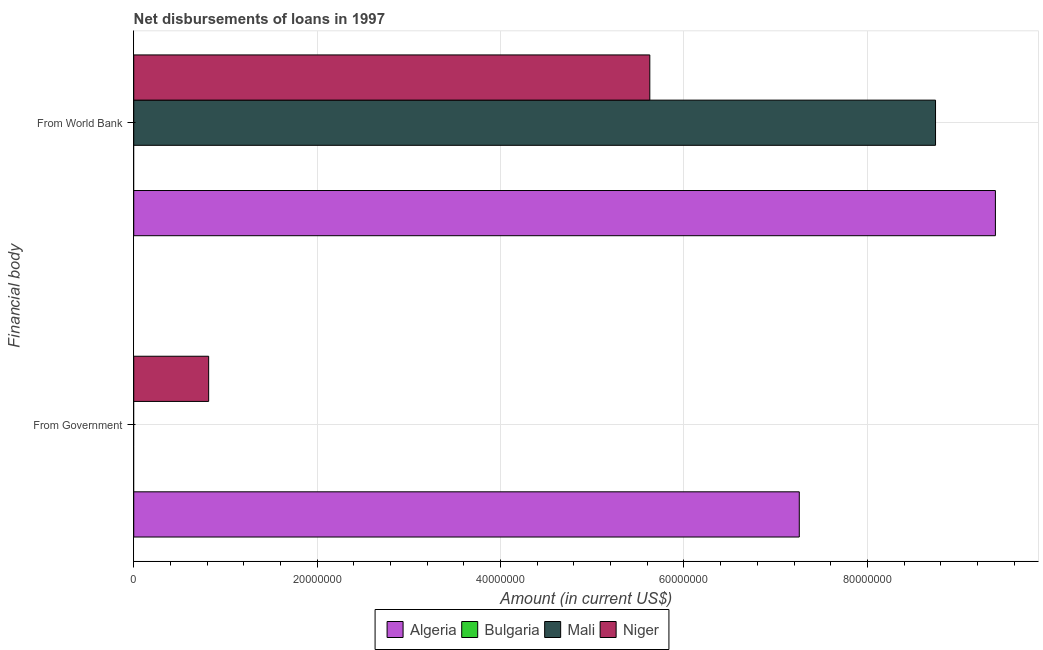How many different coloured bars are there?
Your response must be concise. 3. Are the number of bars per tick equal to the number of legend labels?
Offer a very short reply. No. Are the number of bars on each tick of the Y-axis equal?
Make the answer very short. No. How many bars are there on the 2nd tick from the top?
Your answer should be compact. 2. How many bars are there on the 2nd tick from the bottom?
Offer a terse response. 3. What is the label of the 2nd group of bars from the top?
Your response must be concise. From Government. What is the net disbursements of loan from government in Bulgaria?
Keep it short and to the point. 0. Across all countries, what is the maximum net disbursements of loan from government?
Offer a very short reply. 7.26e+07. Across all countries, what is the minimum net disbursements of loan from world bank?
Offer a very short reply. 0. In which country was the net disbursements of loan from world bank maximum?
Ensure brevity in your answer.  Algeria. What is the total net disbursements of loan from government in the graph?
Your answer should be compact. 8.07e+07. What is the difference between the net disbursements of loan from world bank in Algeria and that in Mali?
Your answer should be compact. 6.53e+06. What is the difference between the net disbursements of loan from government in Algeria and the net disbursements of loan from world bank in Niger?
Your answer should be very brief. 1.63e+07. What is the average net disbursements of loan from world bank per country?
Make the answer very short. 5.94e+07. What is the difference between the net disbursements of loan from world bank and net disbursements of loan from government in Niger?
Your response must be concise. 4.81e+07. In how many countries, is the net disbursements of loan from world bank greater than 84000000 US$?
Offer a terse response. 2. What is the ratio of the net disbursements of loan from government in Algeria to that in Niger?
Ensure brevity in your answer.  8.88. In how many countries, is the net disbursements of loan from government greater than the average net disbursements of loan from government taken over all countries?
Give a very brief answer. 1. Are all the bars in the graph horizontal?
Your response must be concise. Yes. How many countries are there in the graph?
Keep it short and to the point. 4. Does the graph contain any zero values?
Keep it short and to the point. Yes. How many legend labels are there?
Give a very brief answer. 4. How are the legend labels stacked?
Offer a very short reply. Horizontal. What is the title of the graph?
Offer a terse response. Net disbursements of loans in 1997. Does "Croatia" appear as one of the legend labels in the graph?
Make the answer very short. No. What is the label or title of the X-axis?
Offer a terse response. Amount (in current US$). What is the label or title of the Y-axis?
Provide a short and direct response. Financial body. What is the Amount (in current US$) in Algeria in From Government?
Offer a very short reply. 7.26e+07. What is the Amount (in current US$) in Niger in From Government?
Offer a terse response. 8.17e+06. What is the Amount (in current US$) in Algeria in From World Bank?
Offer a terse response. 9.40e+07. What is the Amount (in current US$) of Bulgaria in From World Bank?
Provide a succinct answer. 0. What is the Amount (in current US$) of Mali in From World Bank?
Provide a short and direct response. 8.74e+07. What is the Amount (in current US$) in Niger in From World Bank?
Ensure brevity in your answer.  5.63e+07. Across all Financial body, what is the maximum Amount (in current US$) in Algeria?
Make the answer very short. 9.40e+07. Across all Financial body, what is the maximum Amount (in current US$) in Mali?
Offer a very short reply. 8.74e+07. Across all Financial body, what is the maximum Amount (in current US$) in Niger?
Provide a short and direct response. 5.63e+07. Across all Financial body, what is the minimum Amount (in current US$) in Algeria?
Your response must be concise. 7.26e+07. Across all Financial body, what is the minimum Amount (in current US$) in Mali?
Offer a very short reply. 0. Across all Financial body, what is the minimum Amount (in current US$) in Niger?
Your answer should be very brief. 8.17e+06. What is the total Amount (in current US$) of Algeria in the graph?
Your answer should be compact. 1.67e+08. What is the total Amount (in current US$) in Mali in the graph?
Make the answer very short. 8.74e+07. What is the total Amount (in current US$) of Niger in the graph?
Your response must be concise. 6.44e+07. What is the difference between the Amount (in current US$) in Algeria in From Government and that in From World Bank?
Keep it short and to the point. -2.14e+07. What is the difference between the Amount (in current US$) in Niger in From Government and that in From World Bank?
Offer a very short reply. -4.81e+07. What is the difference between the Amount (in current US$) of Algeria in From Government and the Amount (in current US$) of Mali in From World Bank?
Your answer should be compact. -1.49e+07. What is the difference between the Amount (in current US$) of Algeria in From Government and the Amount (in current US$) of Niger in From World Bank?
Ensure brevity in your answer.  1.63e+07. What is the average Amount (in current US$) of Algeria per Financial body?
Ensure brevity in your answer.  8.33e+07. What is the average Amount (in current US$) of Bulgaria per Financial body?
Your response must be concise. 0. What is the average Amount (in current US$) in Mali per Financial body?
Provide a succinct answer. 4.37e+07. What is the average Amount (in current US$) in Niger per Financial body?
Offer a very short reply. 3.22e+07. What is the difference between the Amount (in current US$) of Algeria and Amount (in current US$) of Niger in From Government?
Provide a short and direct response. 6.44e+07. What is the difference between the Amount (in current US$) of Algeria and Amount (in current US$) of Mali in From World Bank?
Keep it short and to the point. 6.53e+06. What is the difference between the Amount (in current US$) of Algeria and Amount (in current US$) of Niger in From World Bank?
Make the answer very short. 3.77e+07. What is the difference between the Amount (in current US$) in Mali and Amount (in current US$) in Niger in From World Bank?
Keep it short and to the point. 3.12e+07. What is the ratio of the Amount (in current US$) of Algeria in From Government to that in From World Bank?
Your answer should be compact. 0.77. What is the ratio of the Amount (in current US$) in Niger in From Government to that in From World Bank?
Offer a terse response. 0.15. What is the difference between the highest and the second highest Amount (in current US$) in Algeria?
Ensure brevity in your answer.  2.14e+07. What is the difference between the highest and the second highest Amount (in current US$) of Niger?
Provide a succinct answer. 4.81e+07. What is the difference between the highest and the lowest Amount (in current US$) in Algeria?
Your response must be concise. 2.14e+07. What is the difference between the highest and the lowest Amount (in current US$) of Mali?
Provide a succinct answer. 8.74e+07. What is the difference between the highest and the lowest Amount (in current US$) in Niger?
Offer a very short reply. 4.81e+07. 